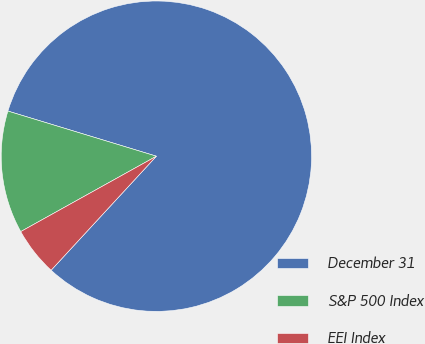Convert chart. <chart><loc_0><loc_0><loc_500><loc_500><pie_chart><fcel>December 31<fcel>S&P 500 Index<fcel>EEI Index<nl><fcel>82.16%<fcel>12.77%<fcel>5.06%<nl></chart> 